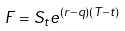Convert formula to latex. <formula><loc_0><loc_0><loc_500><loc_500>F = S _ { t } e ^ { ( r - q ) ( T - t ) }</formula> 